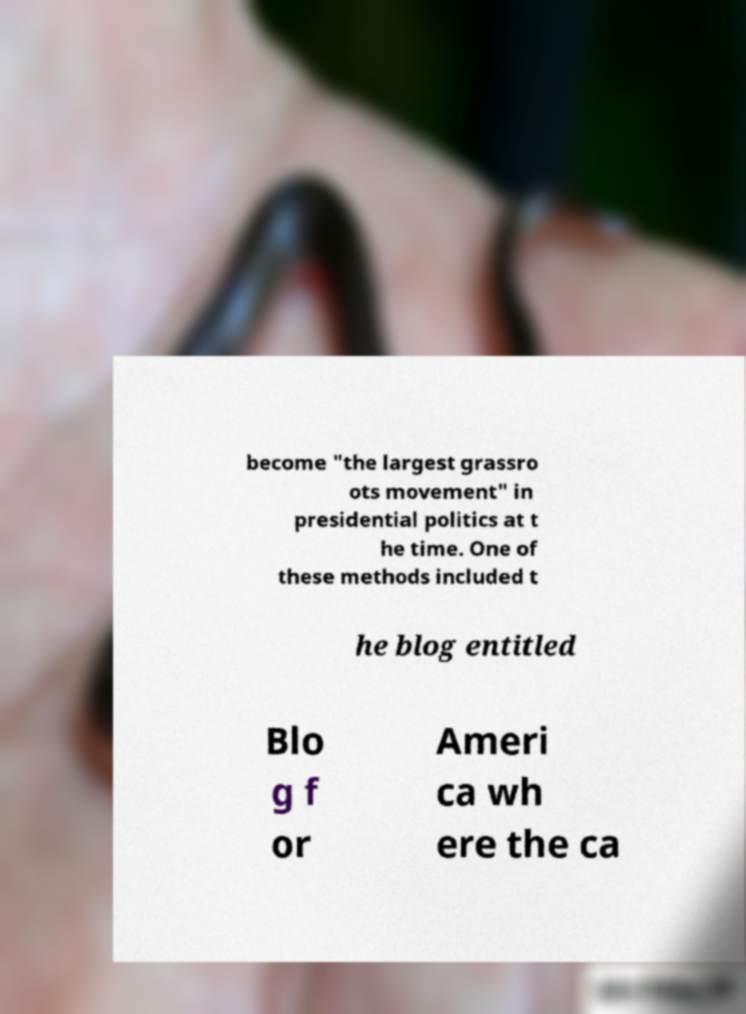For documentation purposes, I need the text within this image transcribed. Could you provide that? become "the largest grassro ots movement" in presidential politics at t he time. One of these methods included t he blog entitled Blo g f or Ameri ca wh ere the ca 